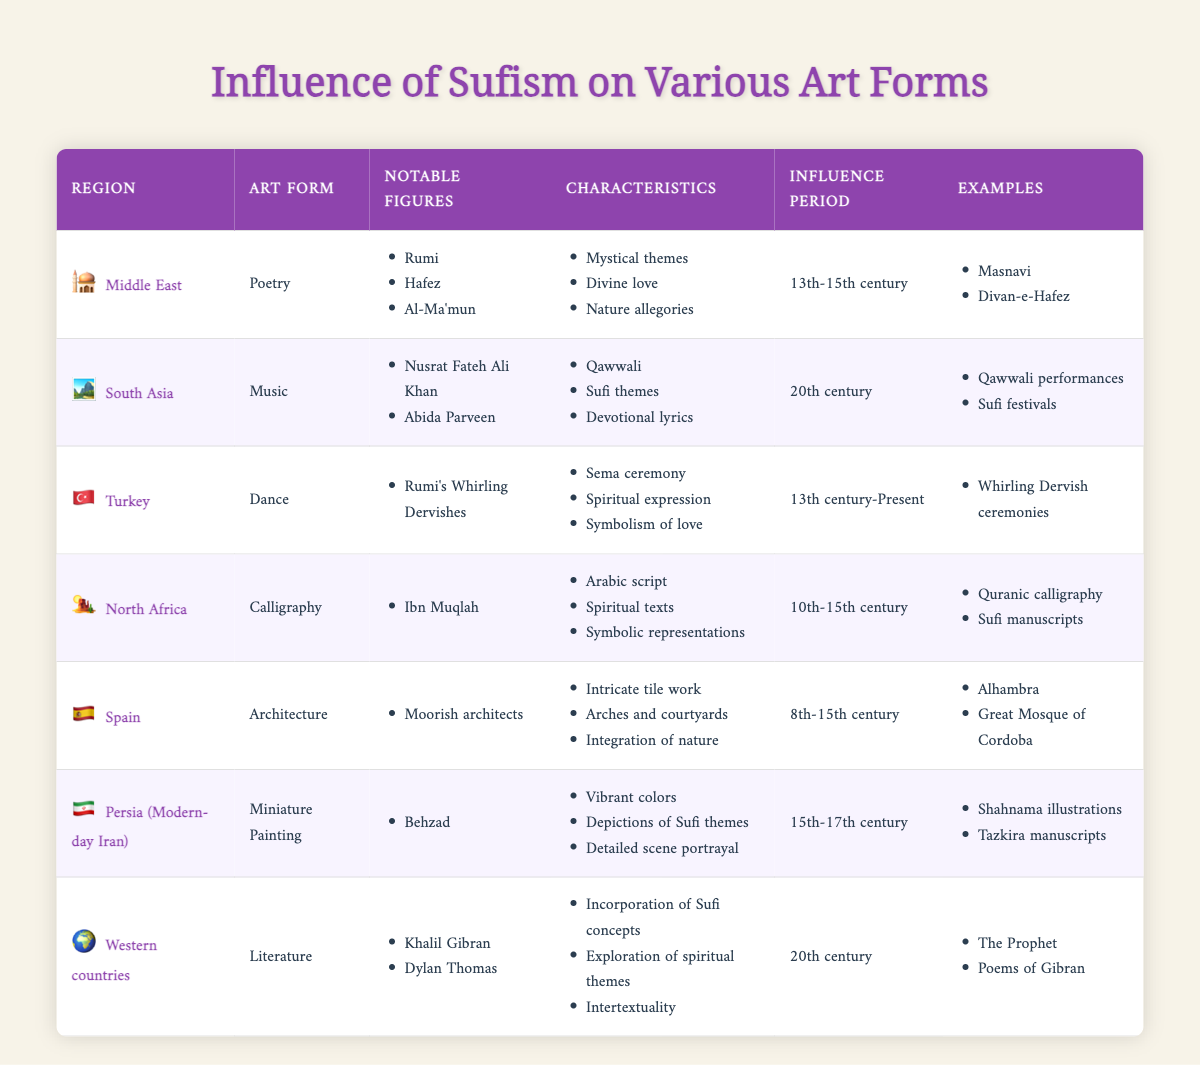What art form is associated with Sufism in South Asia? The table indicates that the art form associated with Sufism in South Asia is Music.
Answer: Music Who are the notable figures in Sufism-related poetry from the Middle East? The table lists Rumi, Hafez, and Al-Ma'mun as the notable figures in Sufism-related poetry from the Middle East.
Answer: Rumi, Hafez, Al-Ma'mun What characteristics of calligraphy in North Africa are mentioned in the table? The table details the characteristics of calligraphy in North Africa as Arabic script, spiritual texts, and symbolic representations.
Answer: Arabic script, spiritual texts, symbolic representations Which region's art form includes the Whirling Dervishes? The table shows that the art form that includes the Whirling Dervishes is Dance in Turkey.
Answer: Dance in Turkey What is the time period of Sufi influence on architecture in Spain? According to the table, the influence period for architecture in Spain is from the 8th to the 15th century.
Answer: 8th-15th century Which art form in Western countries incorporates Sufi concepts? The table specifies that Literature in Western countries incorporates Sufi concepts.
Answer: Literature Count the number of notable figures listed for Music in South Asia. The table indicates that there are two notable figures listed for Music in South Asia: Nusrat Fateh Ali Khan and Abida Parveen.
Answer: 2 What are the common themes found in poetry from the Middle East related to Sufism? The table lists the common themes in Middle Eastern poetry as mystical themes, divine love, and nature allegories.
Answer: Mystical themes, divine love, nature allegories Is there any mention of Sufi manuscripts in North Africa? Yes, the table states that Quranic calligraphy and Sufi manuscripts are examples related to calligraphy in North Africa.
Answer: Yes Which art form has the longest influence period according to the table? To find the longest influence period, we compare the periods: Dance in Turkey (13th century-Present), and Miniature Painting has the next longest (15th-17th century). Thus, Dance has the longest period since it is still ongoing.
Answer: Dance in Turkey 